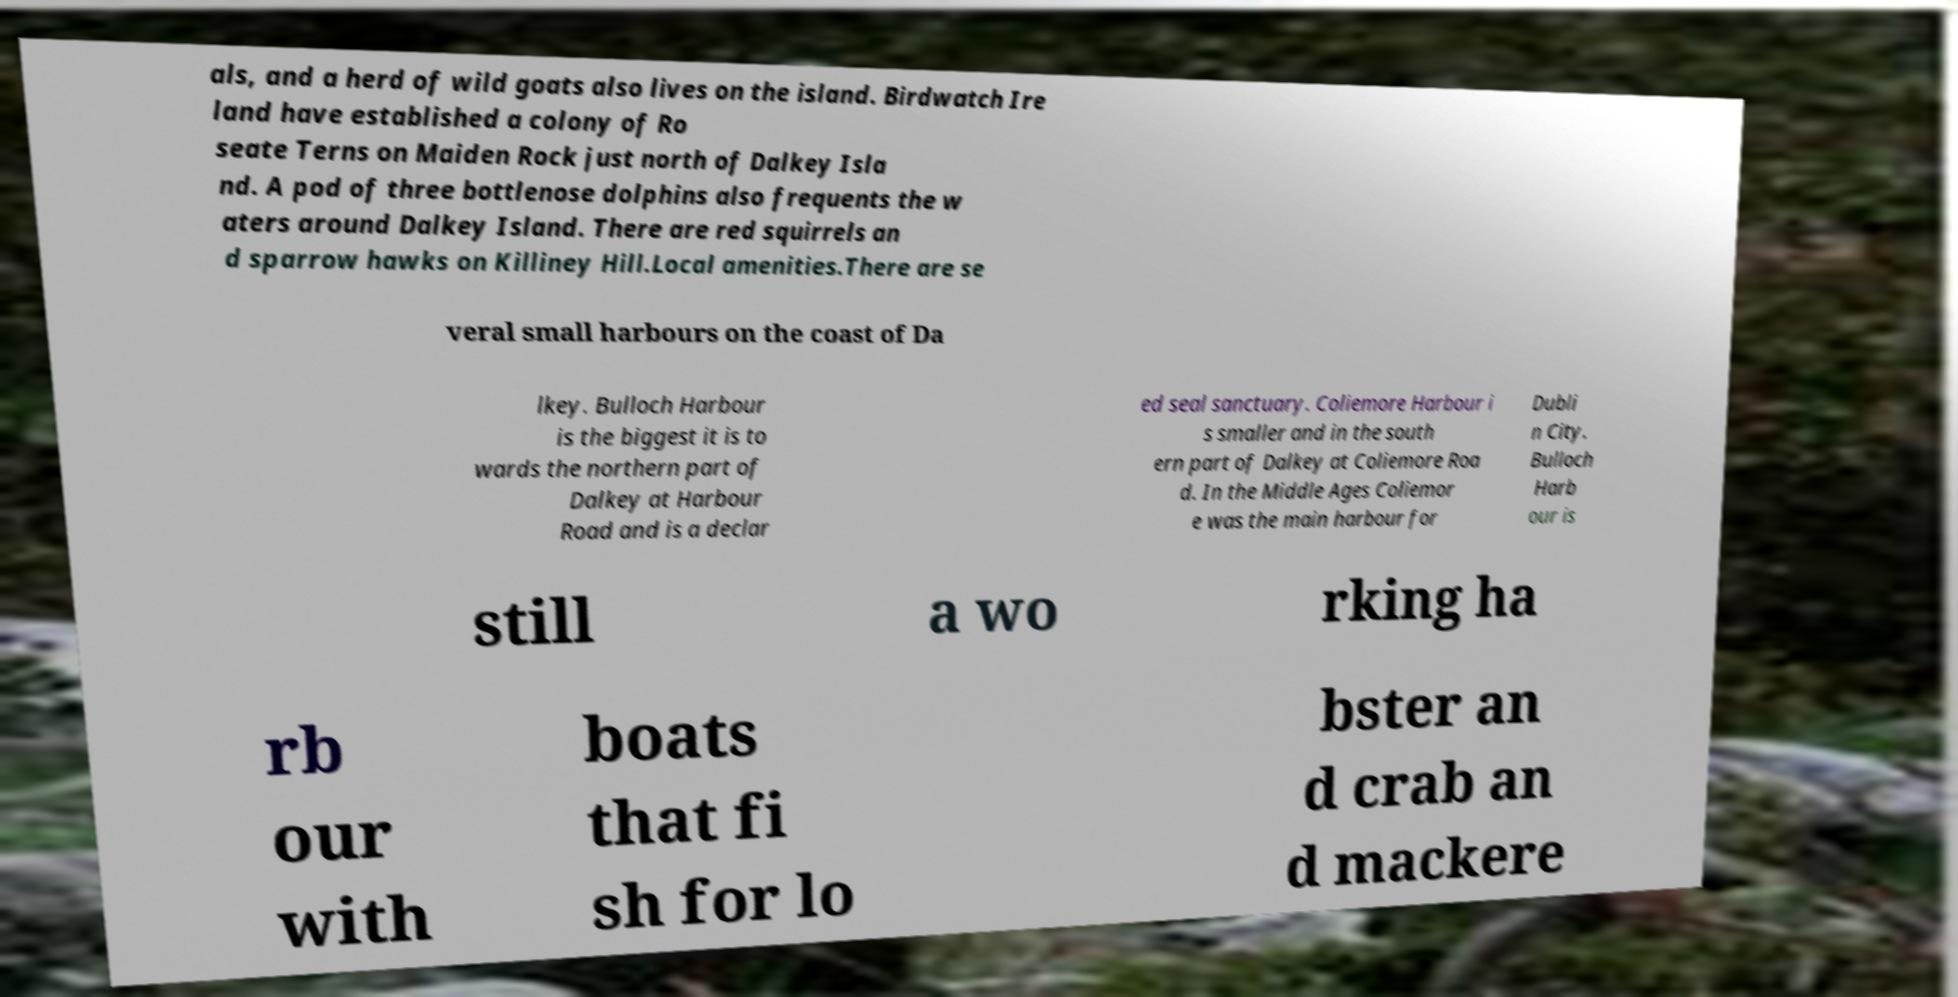Can you read and provide the text displayed in the image?This photo seems to have some interesting text. Can you extract and type it out for me? als, and a herd of wild goats also lives on the island. Birdwatch Ire land have established a colony of Ro seate Terns on Maiden Rock just north of Dalkey Isla nd. A pod of three bottlenose dolphins also frequents the w aters around Dalkey Island. There are red squirrels an d sparrow hawks on Killiney Hill.Local amenities.There are se veral small harbours on the coast of Da lkey. Bulloch Harbour is the biggest it is to wards the northern part of Dalkey at Harbour Road and is a declar ed seal sanctuary. Coliemore Harbour i s smaller and in the south ern part of Dalkey at Coliemore Roa d. In the Middle Ages Coliemor e was the main harbour for Dubli n City. Bulloch Harb our is still a wo rking ha rb our with boats that fi sh for lo bster an d crab an d mackere 